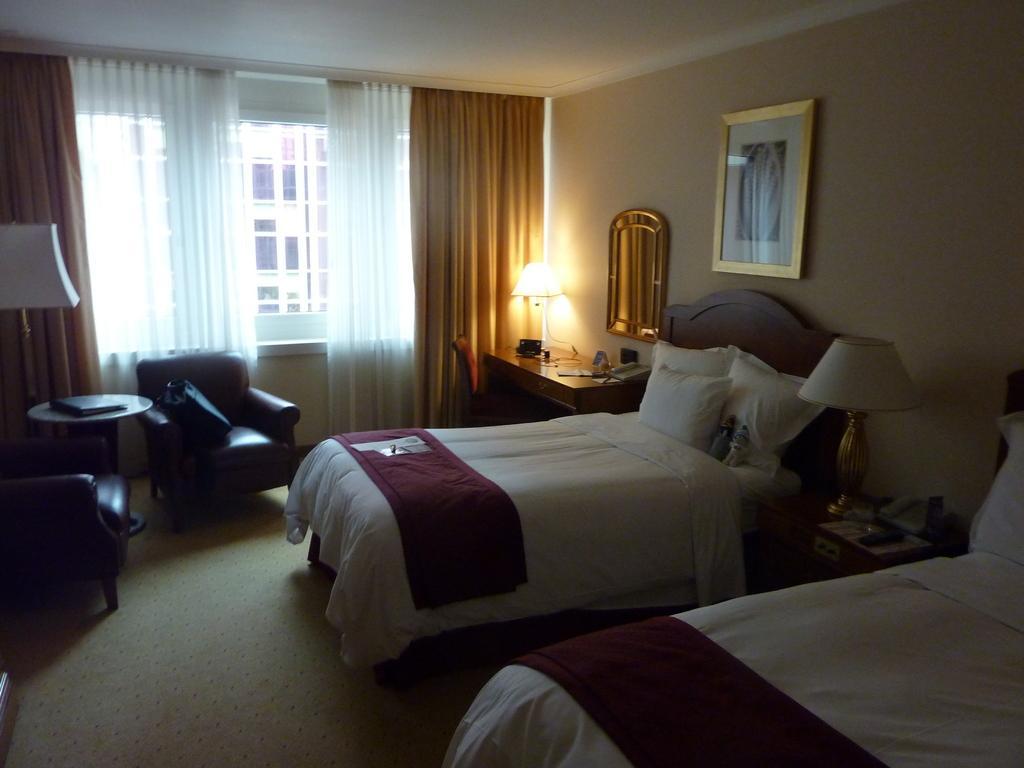Please provide a concise description of this image. In this image, there are two beds. This bed contains pillow and covered with bed sheet. There is a photo frame attached to the wall. There is a window contains curtains. There is a table in front of the wall. This table contains telephone and lamp. There is a chair in front of the table. There is a couch in front of the window. 